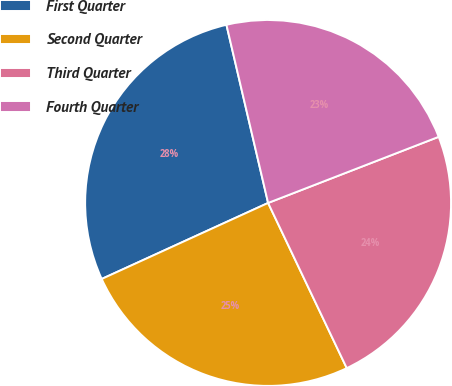<chart> <loc_0><loc_0><loc_500><loc_500><pie_chart><fcel>First Quarter<fcel>Second Quarter<fcel>Third Quarter<fcel>Fourth Quarter<nl><fcel>28.16%<fcel>25.25%<fcel>23.81%<fcel>22.77%<nl></chart> 